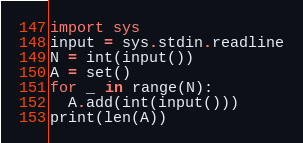<code> <loc_0><loc_0><loc_500><loc_500><_Python_>import sys
input = sys.stdin.readline
N = int(input())
A = set()
for _ in range(N):
  A.add(int(input()))
print(len(A))</code> 